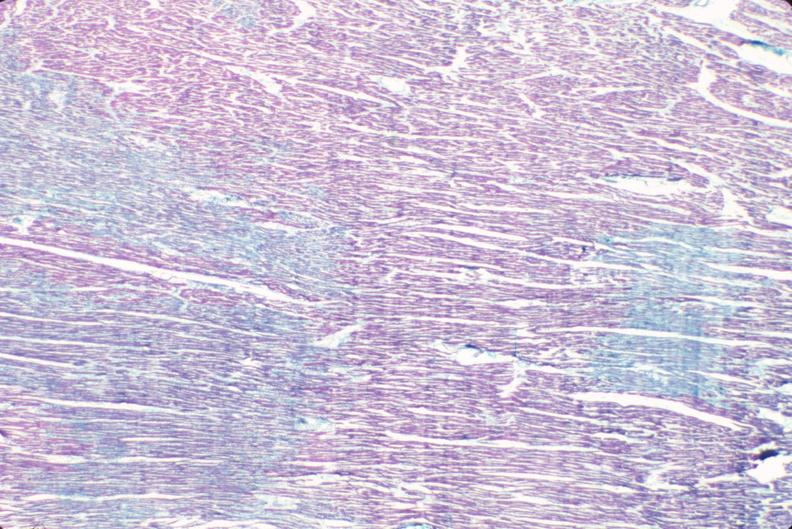what stain?
Answer the question using a single word or phrase. Aldehyde fuscin 